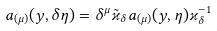<formula> <loc_0><loc_0><loc_500><loc_500>a _ { ( \mu ) } ( y , \delta \eta ) = \delta ^ { \mu } \tilde { \varkappa } _ { \delta } a _ { ( \mu ) } ( y , \eta ) \varkappa _ { \delta } ^ { - 1 }</formula> 